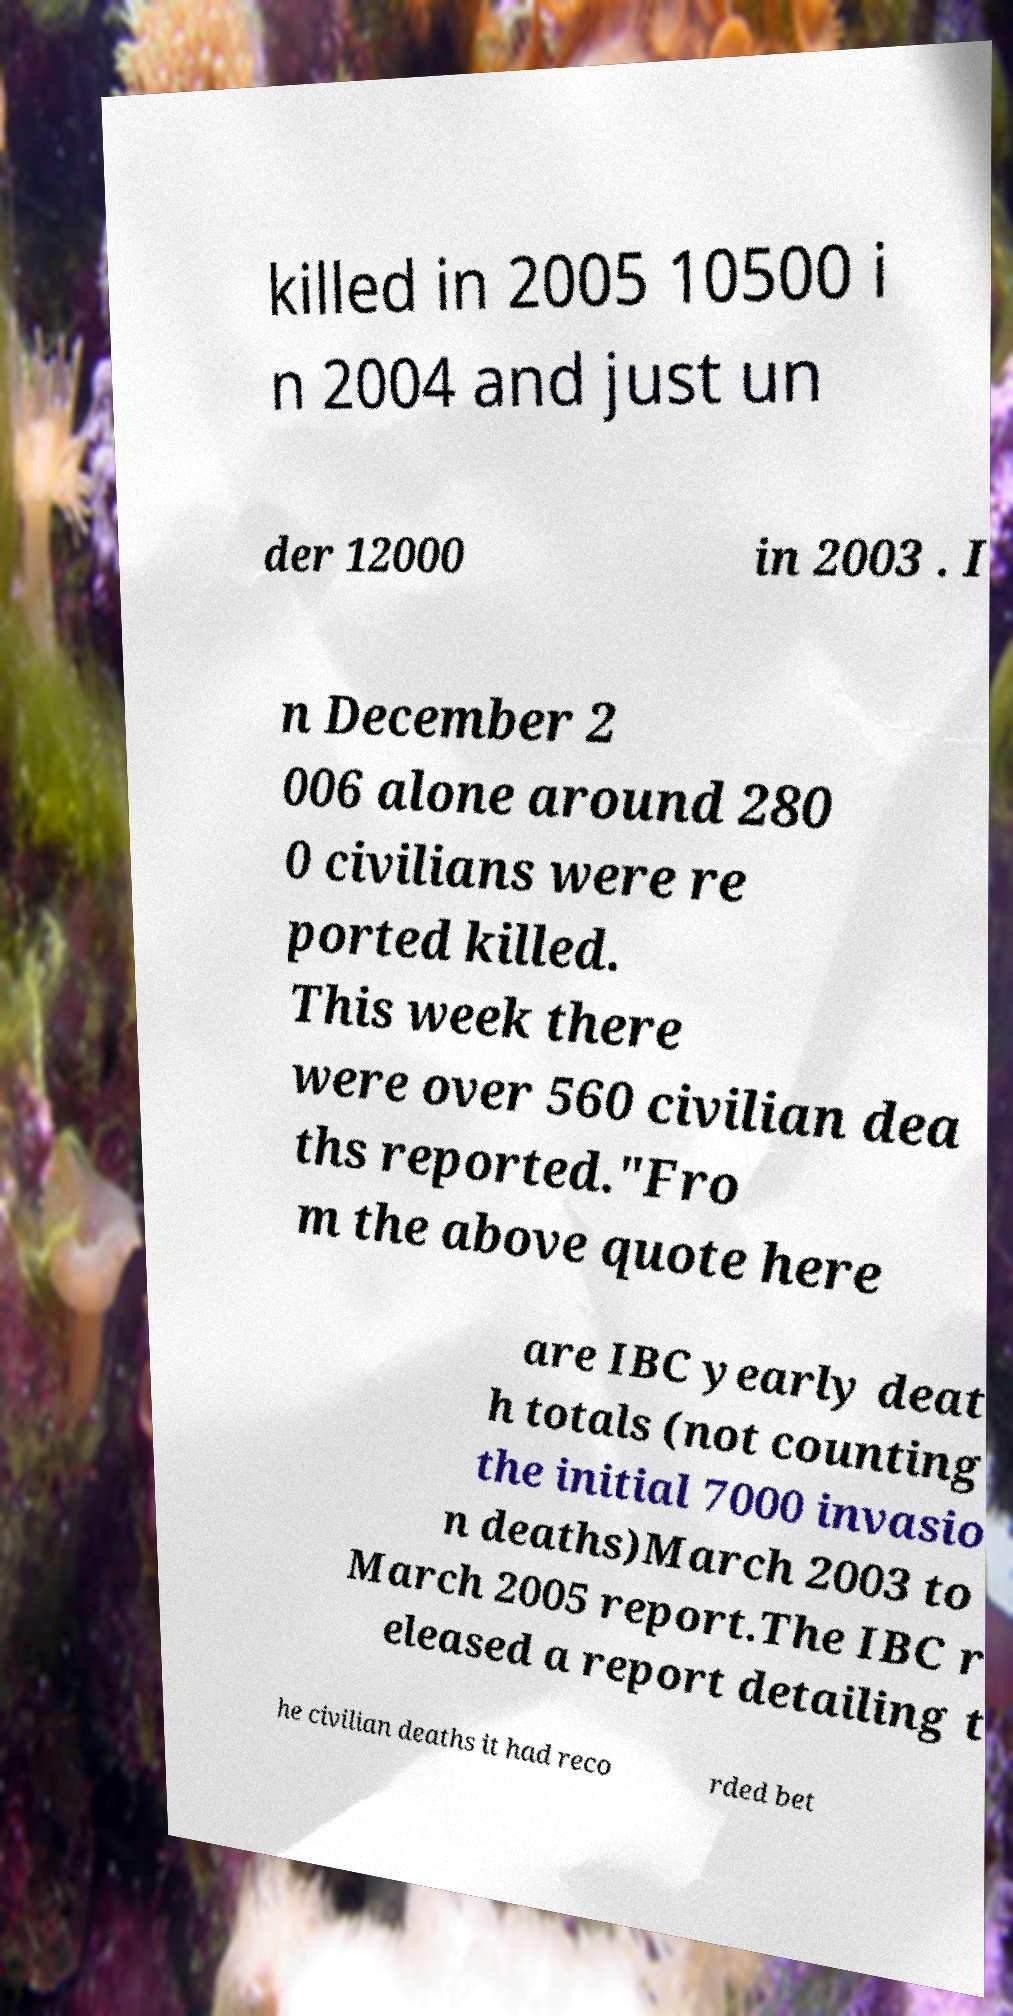What messages or text are displayed in this image? I need them in a readable, typed format. killed in 2005 10500 i n 2004 and just un der 12000 in 2003 . I n December 2 006 alone around 280 0 civilians were re ported killed. This week there were over 560 civilian dea ths reported."Fro m the above quote here are IBC yearly deat h totals (not counting the initial 7000 invasio n deaths)March 2003 to March 2005 report.The IBC r eleased a report detailing t he civilian deaths it had reco rded bet 